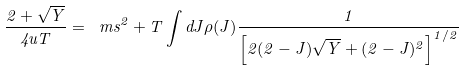<formula> <loc_0><loc_0><loc_500><loc_500>\frac { 2 + \sqrt { Y } } { 4 u T } = \ m s ^ { 2 } + T \int d J \rho ( J ) \frac { 1 } { \left [ 2 ( 2 - J ) \sqrt { Y } + ( 2 - J ) ^ { 2 } \right ] ^ { 1 / 2 } }</formula> 